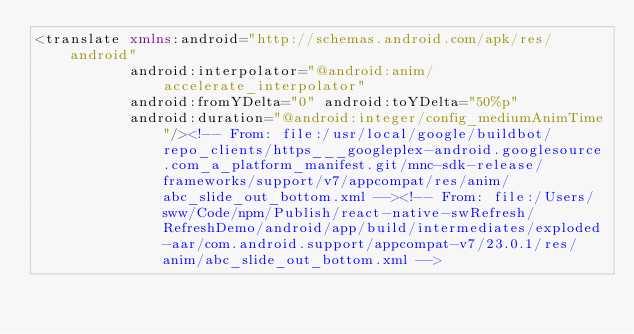Convert code to text. <code><loc_0><loc_0><loc_500><loc_500><_XML_><translate xmlns:android="http://schemas.android.com/apk/res/android"
           android:interpolator="@android:anim/accelerate_interpolator"
           android:fromYDelta="0" android:toYDelta="50%p"
           android:duration="@android:integer/config_mediumAnimTime"/><!-- From: file:/usr/local/google/buildbot/repo_clients/https___googleplex-android.googlesource.com_a_platform_manifest.git/mnc-sdk-release/frameworks/support/v7/appcompat/res/anim/abc_slide_out_bottom.xml --><!-- From: file:/Users/sww/Code/npm/Publish/react-native-swRefresh/RefreshDemo/android/app/build/intermediates/exploded-aar/com.android.support/appcompat-v7/23.0.1/res/anim/abc_slide_out_bottom.xml --></code> 